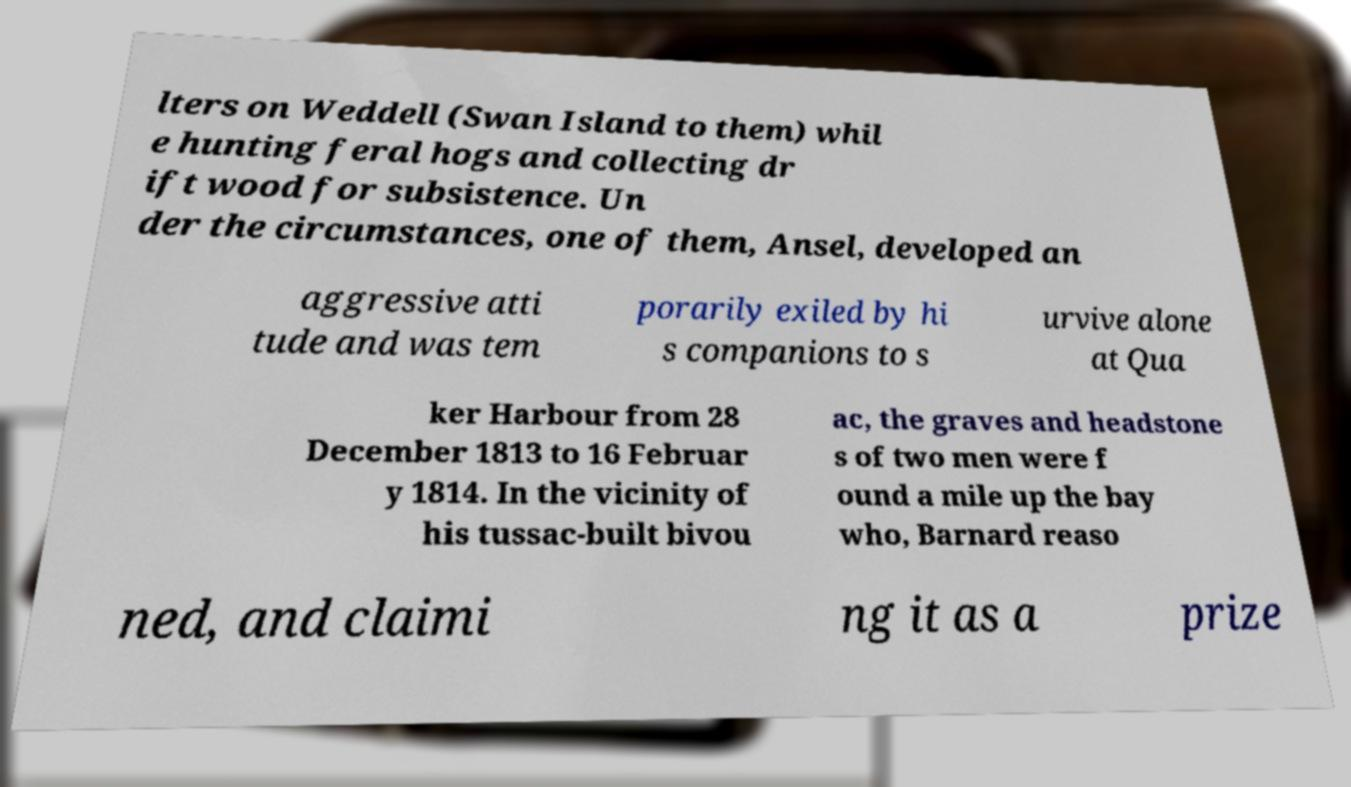There's text embedded in this image that I need extracted. Can you transcribe it verbatim? lters on Weddell (Swan Island to them) whil e hunting feral hogs and collecting dr ift wood for subsistence. Un der the circumstances, one of them, Ansel, developed an aggressive atti tude and was tem porarily exiled by hi s companions to s urvive alone at Qua ker Harbour from 28 December 1813 to 16 Februar y 1814. In the vicinity of his tussac-built bivou ac, the graves and headstone s of two men were f ound a mile up the bay who, Barnard reaso ned, and claimi ng it as a prize 